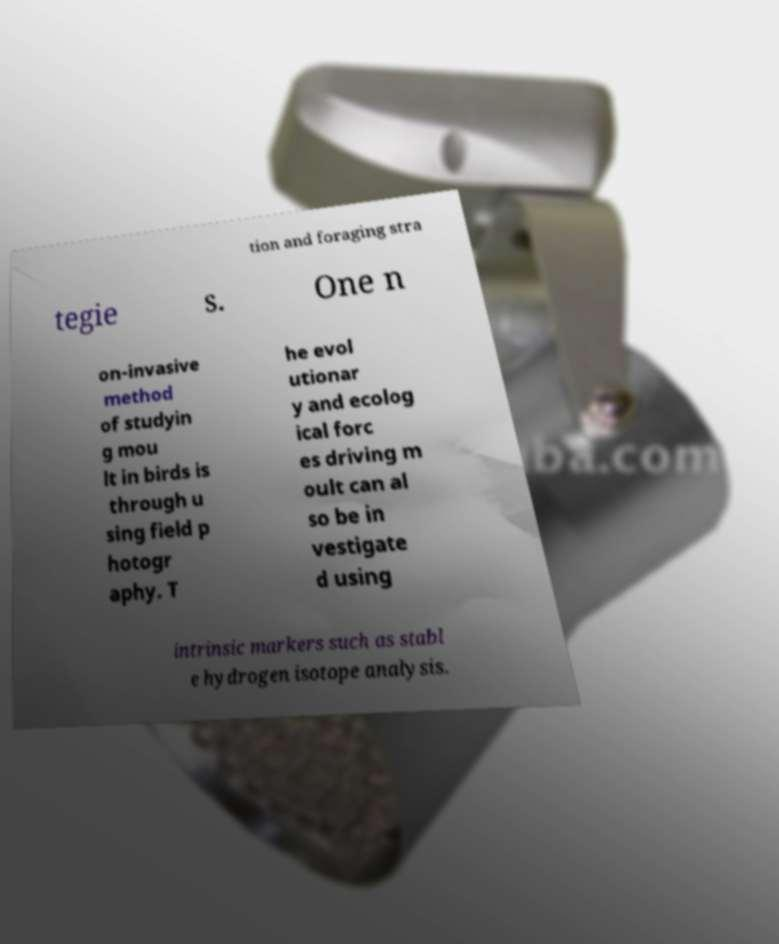For documentation purposes, I need the text within this image transcribed. Could you provide that? tion and foraging stra tegie s. One n on-invasive method of studyin g mou lt in birds is through u sing field p hotogr aphy. T he evol utionar y and ecolog ical forc es driving m oult can al so be in vestigate d using intrinsic markers such as stabl e hydrogen isotope analysis. 